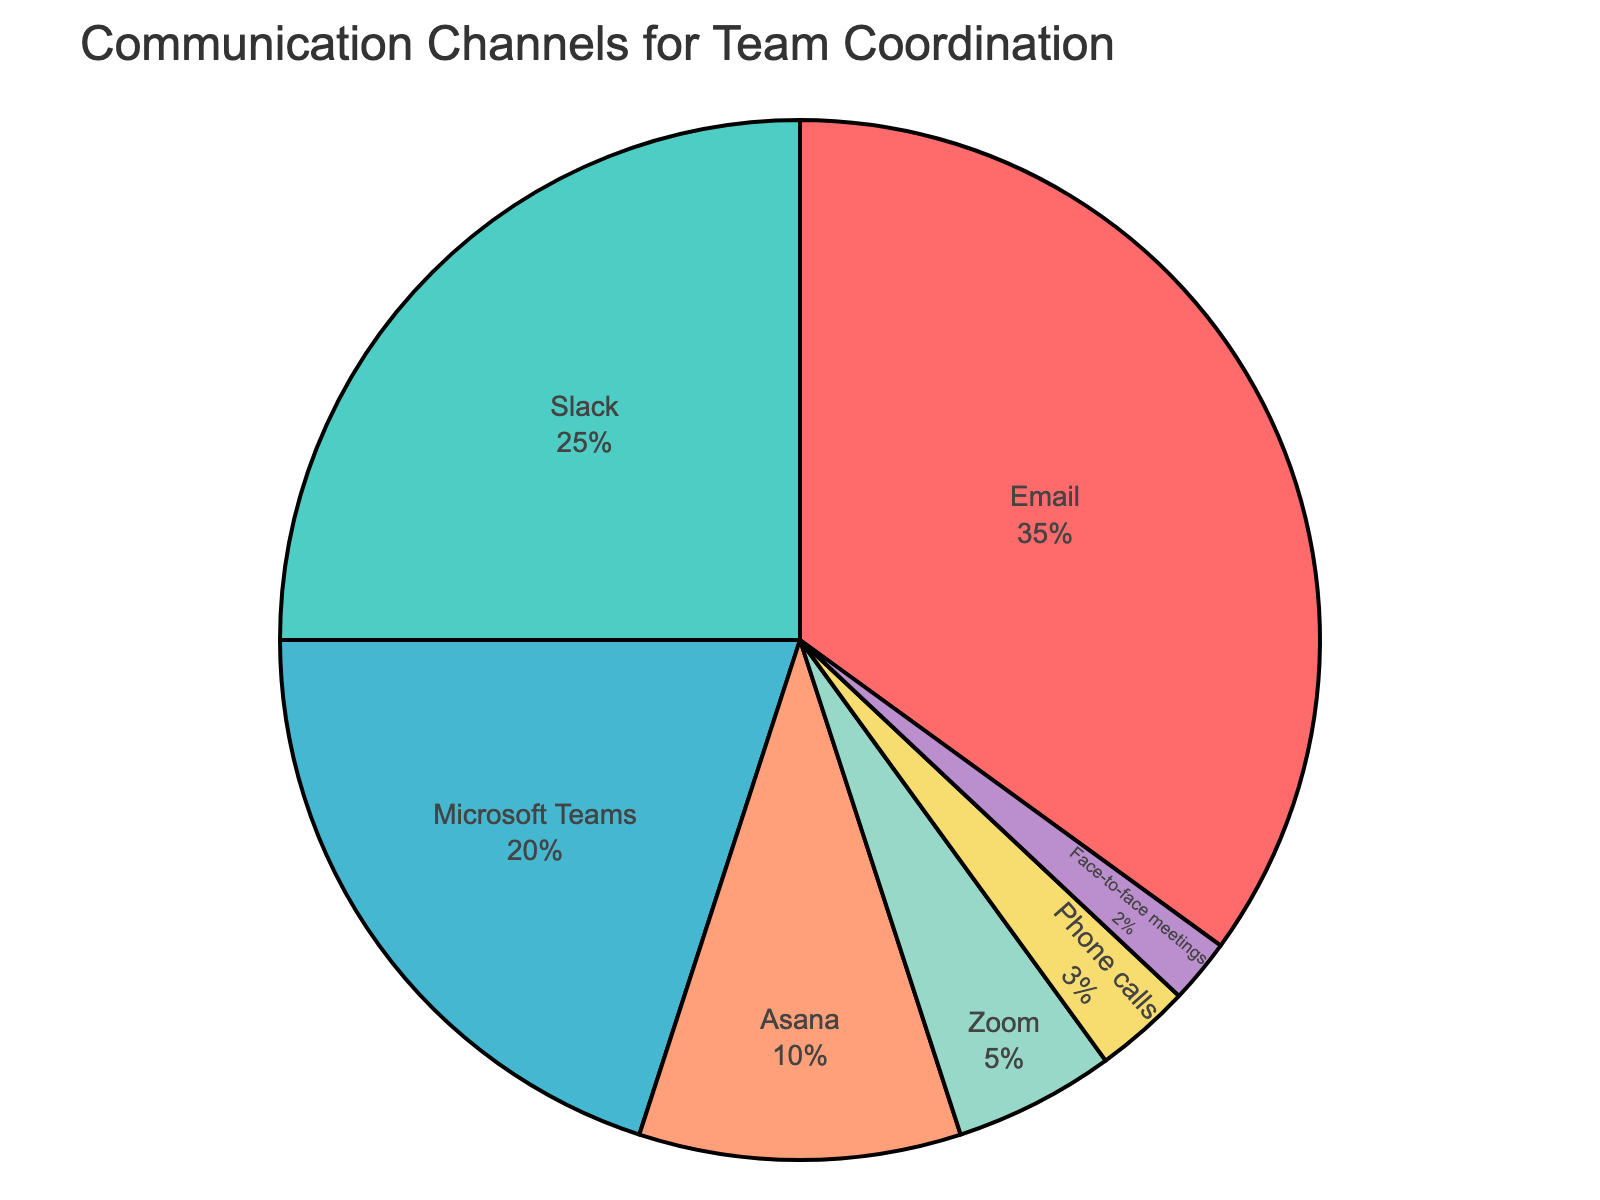what percentage of communication channels is made up by Slack and Microsoft Teams combined? First, identify the percentages for Slack and Microsoft Teams, which are 25% and 20% respectively. Add these two values together: 25% + 20% = 45%.
Answer: 45% Which communication channel is used the least? Identify the communication channel with the smallest percentage. From the data, Face-to-face meetings have the lowest percentage at 2%.
Answer: Face-to-face meetings Is the percentage of Asana users greater than the combined percentage of Phone calls and Face-to-face meetings? Identify the percentages for Asana, Phone calls, and Face-to-face meetings: Asana is 10%, Phone calls are 3%, and Face-to-face meetings are 2%. Add Phone calls and Face-to-face meetings: 3% + 2% = 5%. Compare 10% (Asana) with 5% (Phone calls + Face-to-face meetings).
Answer: Yes Which channel is represented by a blue color? In the pie chart, locate the area filled with blue. The blue section represents Microsoft Teams.
Answer: Microsoft Teams What is the difference between the percentages of Email and Zoom? Identify the percentages for Email and Zoom: Email is 35% and Zoom is 5%. Subtract the smaller percentage from the larger one: 35% - 5% = 30%.
Answer: 30% Rank the communication channels from most to least used. List all channels in order of their percentages: Email (35%), Slack (25%), Microsoft Teams (20%), Asana (10%), Zoom (5%), Phone calls (3%), and Face-to-face meetings (2%).
Answer: Email, Slack, Microsoft Teams, Asana, Zoom, Phone calls, Face-to-face meetings What percentage of communication is through real-time interactions (Slack, Microsoft Teams, Zoom, Phone calls, Face-to-face meetings)? Identify the percentages for Slack, Microsoft Teams, Zoom, Phone calls, and Face-to-face meetings: 25%, 20%, 5%, 3%, and 2% respectively. Add these values together: 25% + 20% + 5% + 3% + 2% = 55%.
Answer: 55% Which channel is used more, Asana or Zoom, and by how much? Identify the percentages for Asana and Zoom: Asana is 10% and Zoom is 5%. Subtract the smaller percentage from the larger one: 10% - 5% = 5%.
Answer: Asana, by 5% 